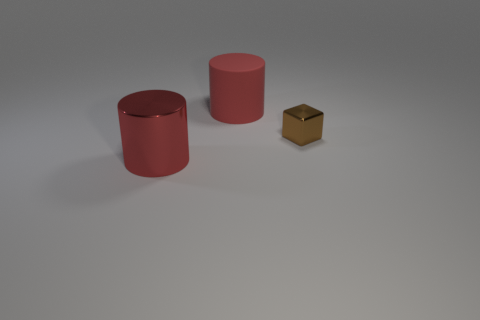Add 3 large brown metal objects. How many objects exist? 6 Subtract 2 cylinders. How many cylinders are left? 0 Subtract all large metal things. Subtract all small metallic blocks. How many objects are left? 1 Add 2 red objects. How many red objects are left? 4 Add 3 cylinders. How many cylinders exist? 5 Subtract 0 brown balls. How many objects are left? 3 Subtract all cubes. How many objects are left? 2 Subtract all brown cylinders. Subtract all blue balls. How many cylinders are left? 2 